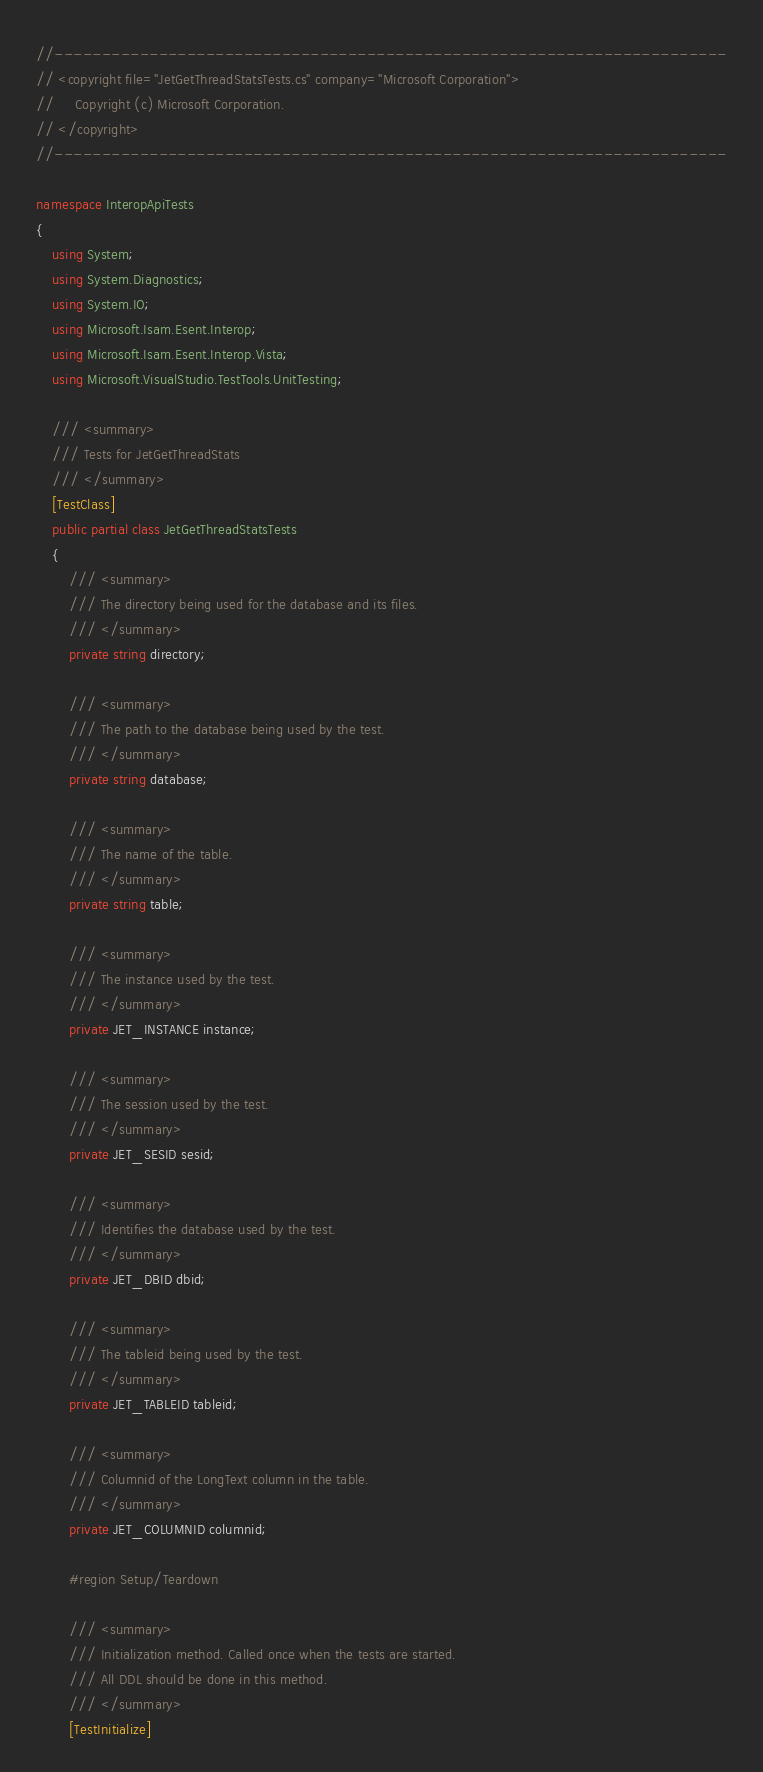<code> <loc_0><loc_0><loc_500><loc_500><_C#_>//-----------------------------------------------------------------------
// <copyright file="JetGetThreadStatsTests.cs" company="Microsoft Corporation">
//     Copyright (c) Microsoft Corporation.
// </copyright>
//-----------------------------------------------------------------------

namespace InteropApiTests
{
    using System;
    using System.Diagnostics;
    using System.IO;
    using Microsoft.Isam.Esent.Interop;
    using Microsoft.Isam.Esent.Interop.Vista;
    using Microsoft.VisualStudio.TestTools.UnitTesting;

    /// <summary>
    /// Tests for JetGetThreadStats
    /// </summary>
    [TestClass]
    public partial class JetGetThreadStatsTests
    {
        /// <summary>
        /// The directory being used for the database and its files.
        /// </summary>
        private string directory;

        /// <summary>
        /// The path to the database being used by the test.
        /// </summary>
        private string database;

        /// <summary>
        /// The name of the table.
        /// </summary>
        private string table;

        /// <summary>
        /// The instance used by the test.
        /// </summary>
        private JET_INSTANCE instance;

        /// <summary>
        /// The session used by the test.
        /// </summary>
        private JET_SESID sesid;

        /// <summary>
        /// Identifies the database used by the test.
        /// </summary>
        private JET_DBID dbid;

        /// <summary>
        /// The tableid being used by the test.
        /// </summary>
        private JET_TABLEID tableid;

        /// <summary>
        /// Columnid of the LongText column in the table.
        /// </summary>
        private JET_COLUMNID columnid;

        #region Setup/Teardown

        /// <summary>
        /// Initialization method. Called once when the tests are started.
        /// All DDL should be done in this method.
        /// </summary>
        [TestInitialize]</code> 